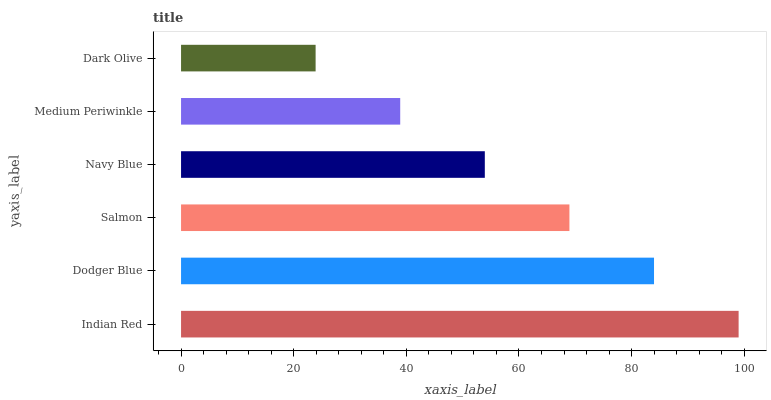Is Dark Olive the minimum?
Answer yes or no. Yes. Is Indian Red the maximum?
Answer yes or no. Yes. Is Dodger Blue the minimum?
Answer yes or no. No. Is Dodger Blue the maximum?
Answer yes or no. No. Is Indian Red greater than Dodger Blue?
Answer yes or no. Yes. Is Dodger Blue less than Indian Red?
Answer yes or no. Yes. Is Dodger Blue greater than Indian Red?
Answer yes or no. No. Is Indian Red less than Dodger Blue?
Answer yes or no. No. Is Salmon the high median?
Answer yes or no. Yes. Is Navy Blue the low median?
Answer yes or no. Yes. Is Medium Periwinkle the high median?
Answer yes or no. No. Is Indian Red the low median?
Answer yes or no. No. 